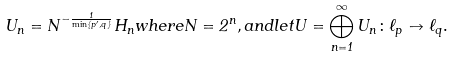<formula> <loc_0><loc_0><loc_500><loc_500>U _ { n } = N ^ { - \frac { 1 } { \min \{ p ^ { \prime } , q \} } } H _ { n } w h e r e N = 2 ^ { n } , a n d l e t U = \bigoplus _ { n = 1 } ^ { \infty } U _ { n } \colon \ell _ { p } \to \ell _ { q } .</formula> 